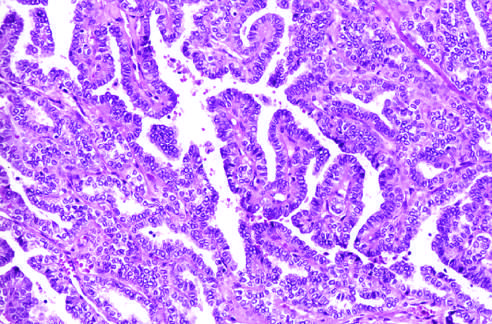re well-formed papillae lined by cells with characteristic empty-appearing nuclei, sometimes termed orphan annie eye nuclei c in this particular example?
Answer the question using a single word or phrase. Yes 